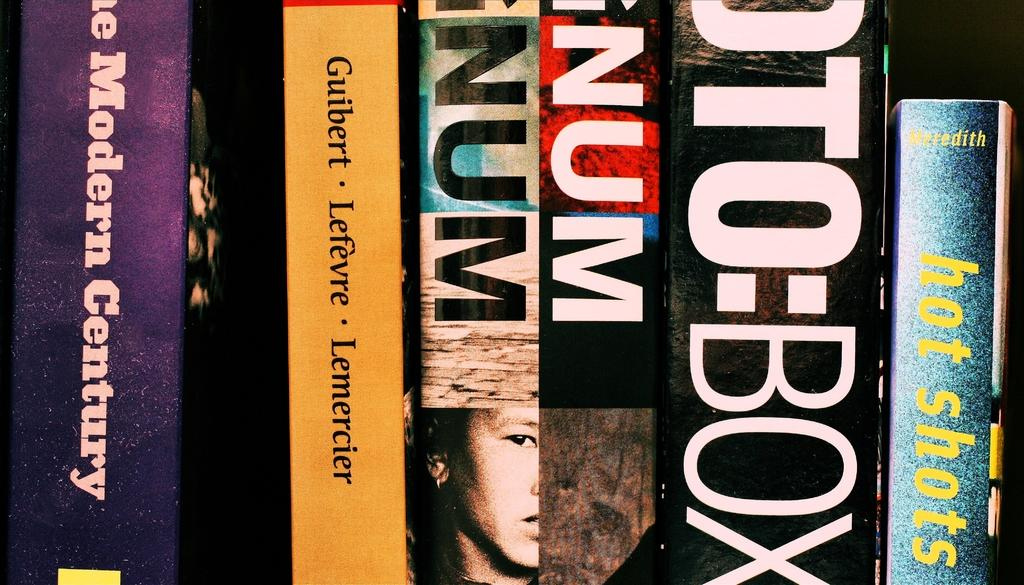<image>
Write a terse but informative summary of the picture. an assortment of books and a yellow on called lefevre 